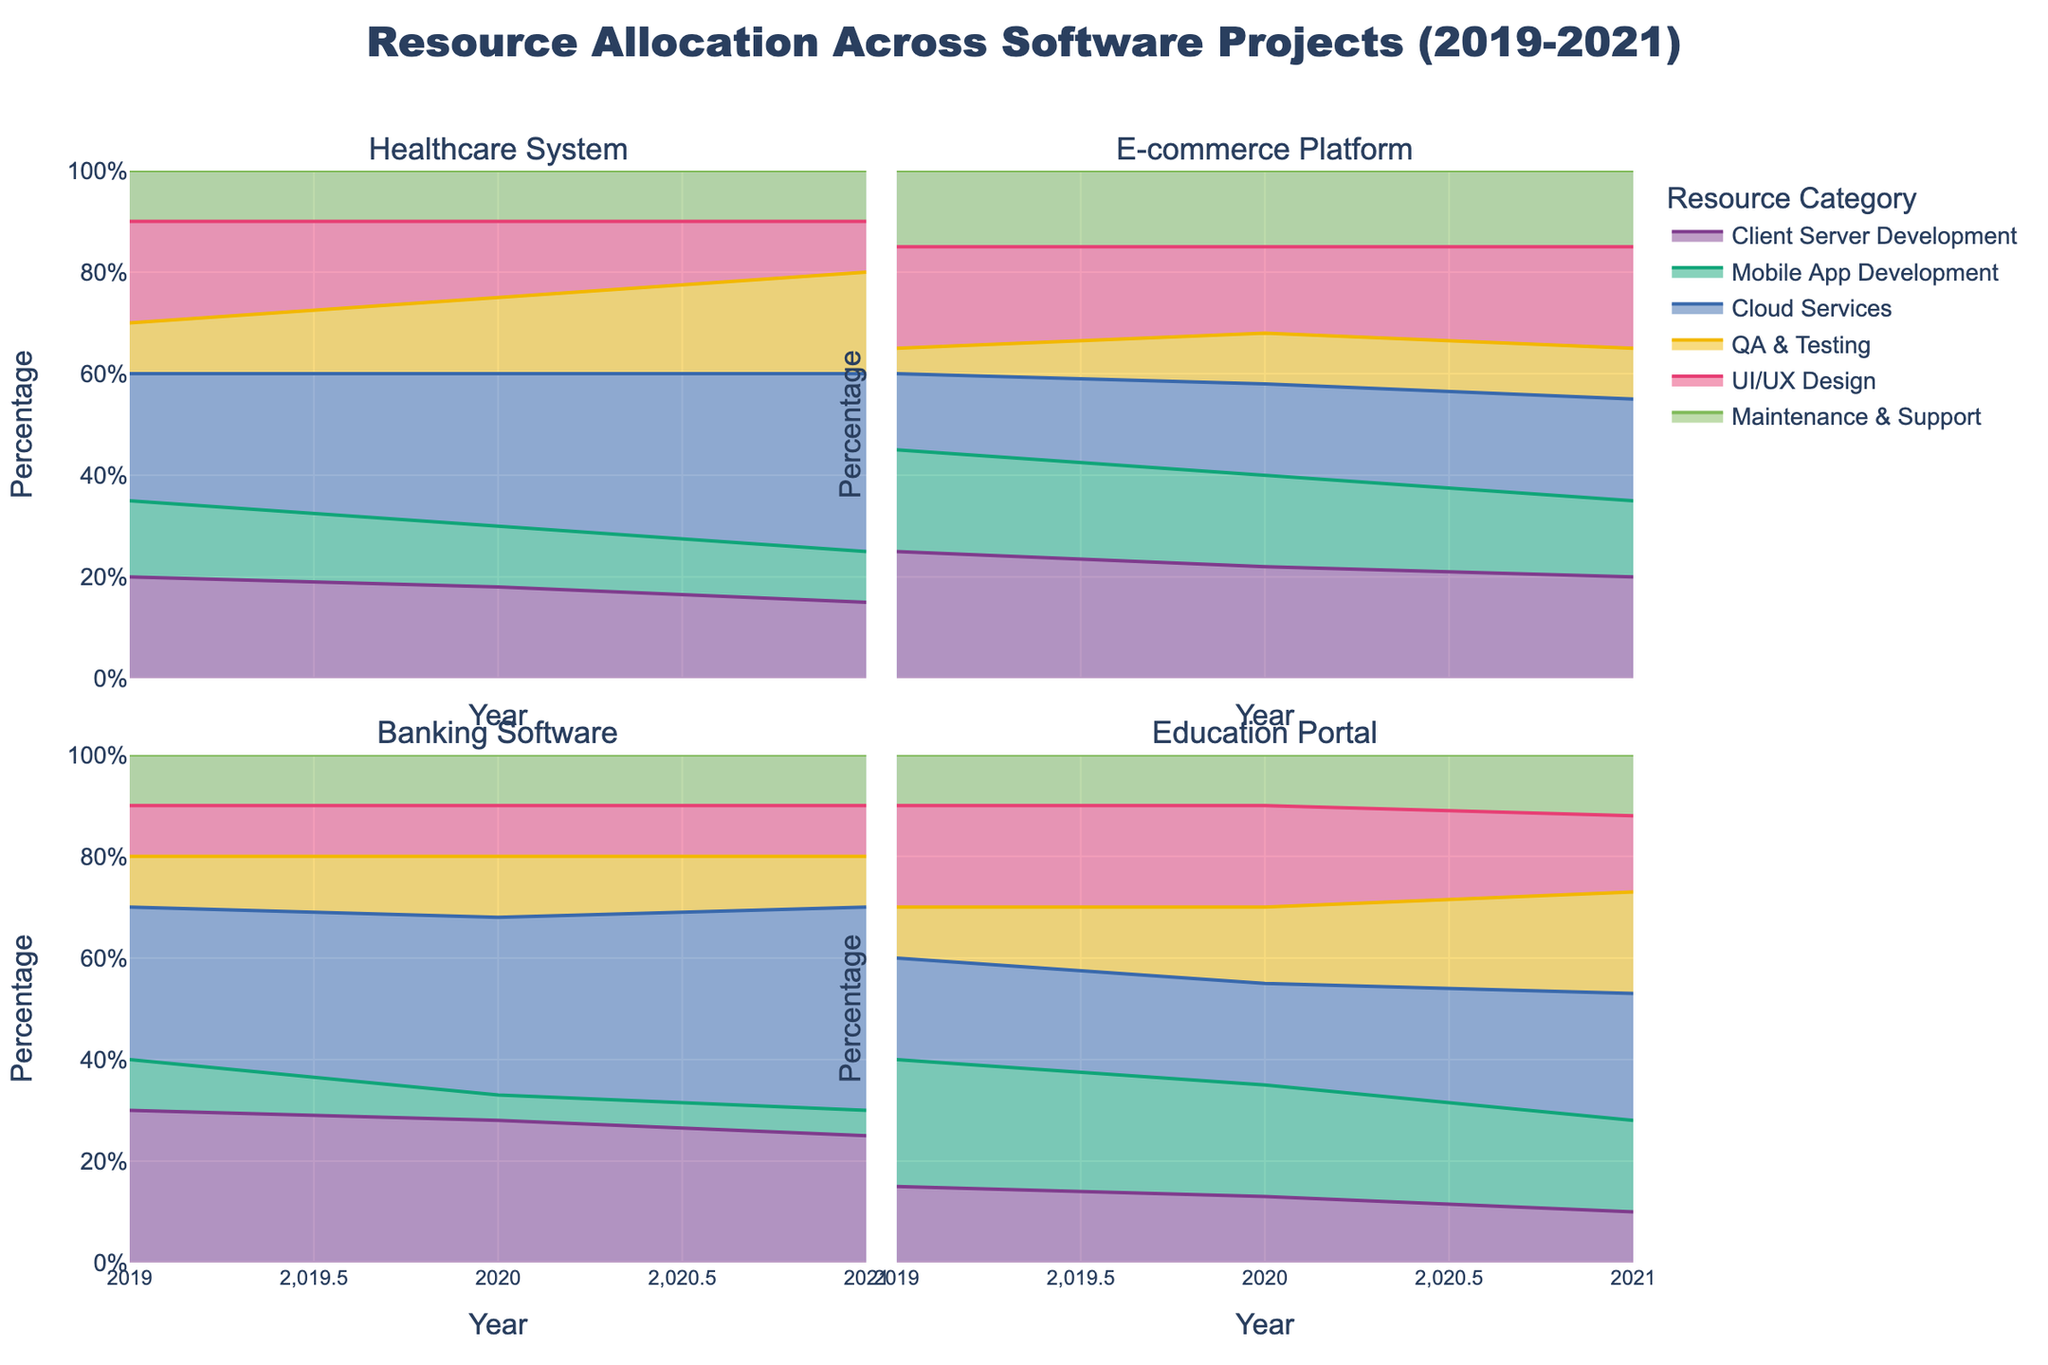What is the overall title of the chart? The title is located at the top center of the chart. It provides a summary of the chart's content.
Answer: Resource Allocation Across Software Projects (2019-2021) What does the y-axis represent in the chart? The y-axis label indicates what is being measured. In this case, it's shown on the left side.
Answer: Percentage How has the resource allocation for 'QA & Testing' changed for the Healthcare System project from 2019 to 2021? Review the specific segments corresponding to 'QA & Testing' in the Healthcare System facets for the years 2019, 2020, and 2021. The area representing 'QA & Testing' has consistently increased.
Answer: Increased In which year did the E-commerce Platform project allocate the highest percentage to 'Cloud Services'? Compare the 'Cloud Services' segment's height in each year for the E-commerce Platform facet.
Answer: 2021 Which project allocated the highest percentage of resources to 'Mobile App Development' in 2019? Check the height of the 'Mobile App Development' segments for each project in 2019.
Answer: Education Portal Has the percentage allocation for 'UI/UX Design' in the Banking Software project changed from 2019 to 2021? Observe the 'UI/UX Design' segments in the Banking Software facet for the years 2019, 2020, and 2021. The percentage remains constant.
Answer: No Which project shows the greatest increase in percentage allocation to 'Cloud Services' from 2019 to 2021? Calculate the difference in percentage allocation to 'Cloud Services' from 2019 to 2021 for each project. The Banking Software project shows the greatest increase.
Answer: Banking Software What is the combined percentage allocation to 'Client Server Development' and 'Maintenance & Support' for the Education Portal project in 2020? Add the percentages of 'Client Server Development' (13%) and 'Maintenance & Support' (10%) in 2020 for the Education Portal.
Answer: 23% Which resource category had the smallest allocation in the Healthcare System project in 2021? Compare the segments for each category within the Healthcare System project facet for 2021.
Answer: UI/UX Design How is the resource distribution among different categories uniform across projects in 2019? Examine the overall shape and relative sizes of the categories across facets for 2019. Note any similarities or differences in distribution.
Answer: Non-uniform 